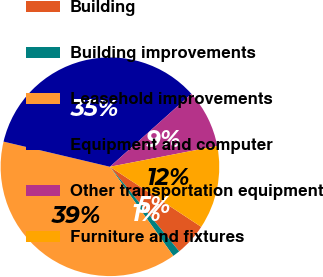Convert chart. <chart><loc_0><loc_0><loc_500><loc_500><pie_chart><fcel>Building<fcel>Building improvements<fcel>Leasehold improvements<fcel>Equipment and computer<fcel>Other transportation equipment<fcel>Furniture and fixtures<nl><fcel>4.82%<fcel>1.08%<fcel>38.53%<fcel>34.69%<fcel>8.57%<fcel>12.31%<nl></chart> 